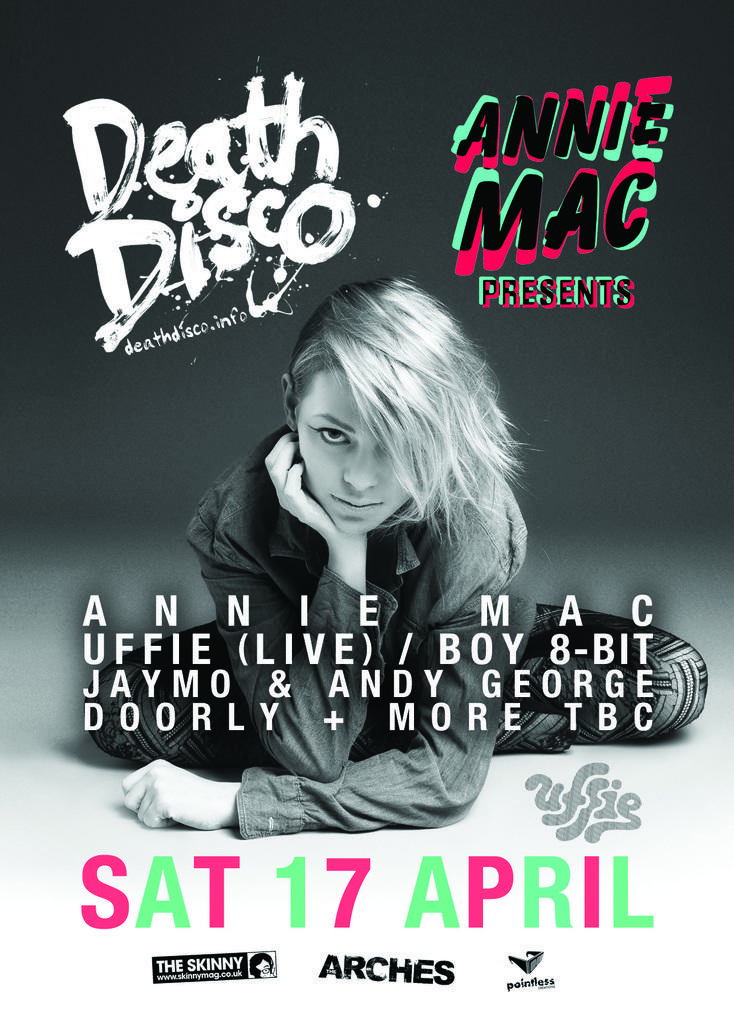What type of image is being described? The image is an advertisement. Can you describe the person in the image? There is a lady sitting in the image. What else can be seen in the image besides the lady? There is text in the background of the image. How does the lady show respect to her father in the image? There is no mention of a father or any action related to respect in the image. 